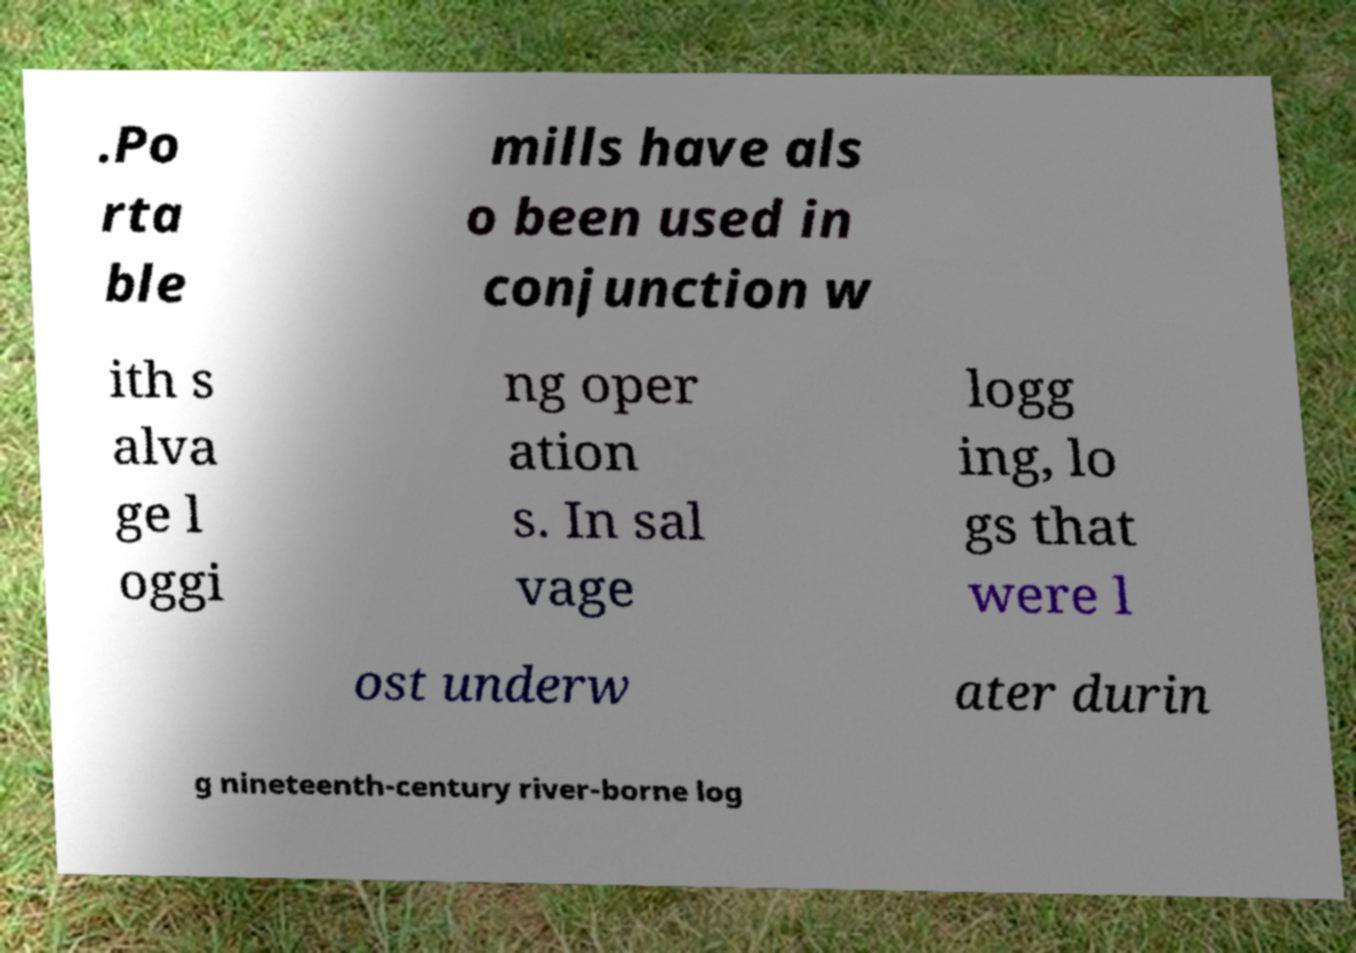Please read and relay the text visible in this image. What does it say? .Po rta ble mills have als o been used in conjunction w ith s alva ge l oggi ng oper ation s. In sal vage logg ing, lo gs that were l ost underw ater durin g nineteenth-century river-borne log 